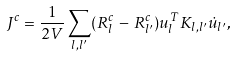Convert formula to latex. <formula><loc_0><loc_0><loc_500><loc_500>J ^ { c } = \frac { 1 } { 2 V } \sum _ { l , l ^ { \prime } } ( R _ { l } ^ { c } \, - \, R _ { l ^ { \prime } } ^ { c } ) u ^ { T } _ { l } K _ { l , l ^ { \prime } } \dot { u } _ { l ^ { \prime } } ,</formula> 